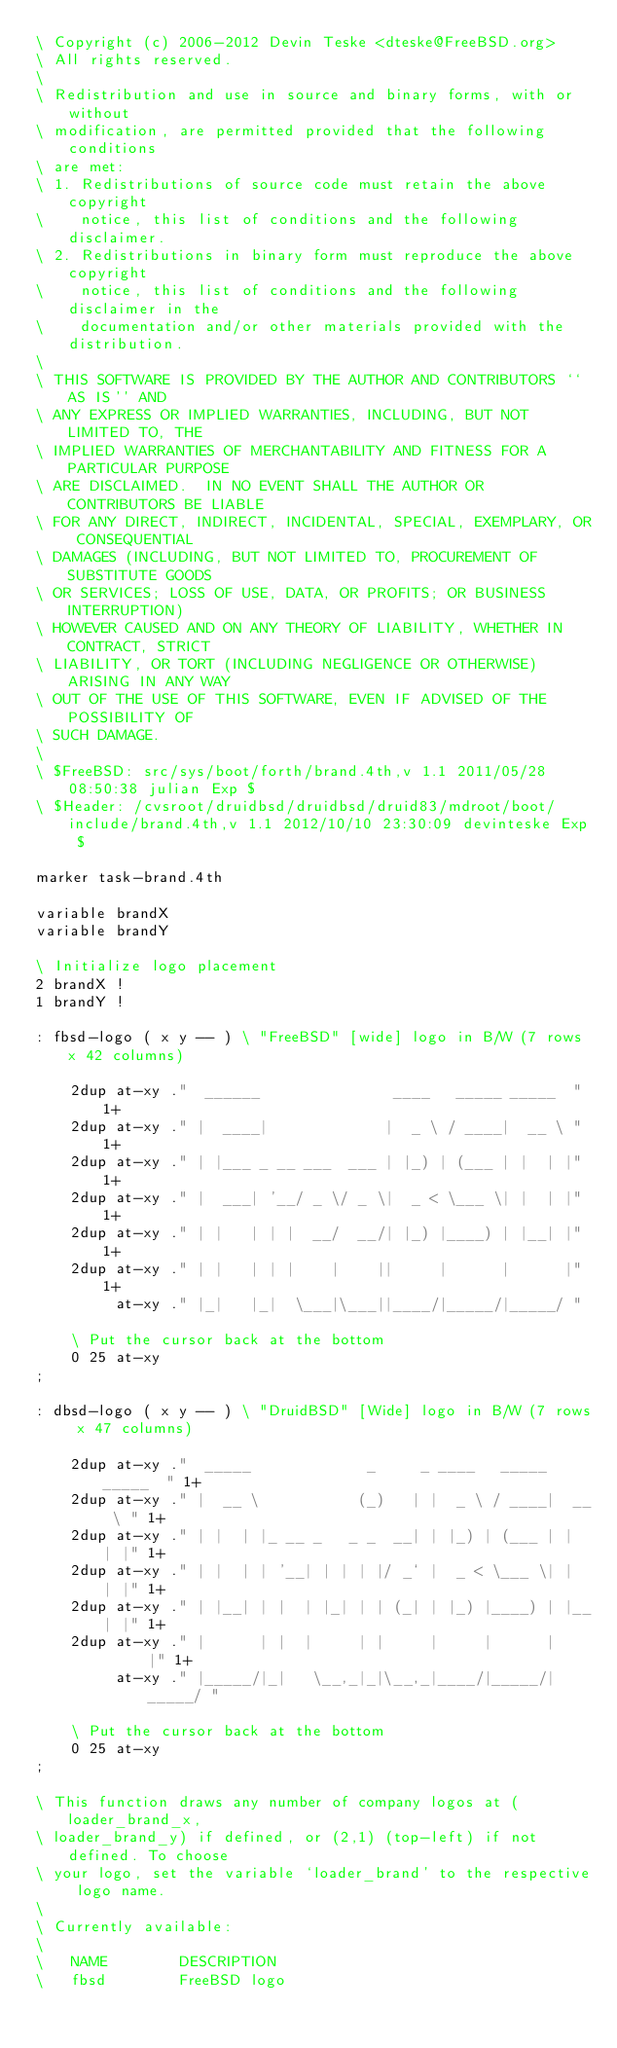<code> <loc_0><loc_0><loc_500><loc_500><_Forth_>\ Copyright (c) 2006-2012 Devin Teske <dteske@FreeBSD.org>
\ All rights reserved.
\ 
\ Redistribution and use in source and binary forms, with or without
\ modification, are permitted provided that the following conditions
\ are met:
\ 1. Redistributions of source code must retain the above copyright
\    notice, this list of conditions and the following disclaimer.
\ 2. Redistributions in binary form must reproduce the above copyright
\    notice, this list of conditions and the following disclaimer in the
\    documentation and/or other materials provided with the distribution.
\ 
\ THIS SOFTWARE IS PROVIDED BY THE AUTHOR AND CONTRIBUTORS ``AS IS'' AND
\ ANY EXPRESS OR IMPLIED WARRANTIES, INCLUDING, BUT NOT LIMITED TO, THE
\ IMPLIED WARRANTIES OF MERCHANTABILITY AND FITNESS FOR A PARTICULAR PURPOSE
\ ARE DISCLAIMED.  IN NO EVENT SHALL THE AUTHOR OR CONTRIBUTORS BE LIABLE
\ FOR ANY DIRECT, INDIRECT, INCIDENTAL, SPECIAL, EXEMPLARY, OR CONSEQUENTIAL
\ DAMAGES (INCLUDING, BUT NOT LIMITED TO, PROCUREMENT OF SUBSTITUTE GOODS
\ OR SERVICES; LOSS OF USE, DATA, OR PROFITS; OR BUSINESS INTERRUPTION)
\ HOWEVER CAUSED AND ON ANY THEORY OF LIABILITY, WHETHER IN CONTRACT, STRICT
\ LIABILITY, OR TORT (INCLUDING NEGLIGENCE OR OTHERWISE) ARISING IN ANY WAY
\ OUT OF THE USE OF THIS SOFTWARE, EVEN IF ADVISED OF THE POSSIBILITY OF
\ SUCH DAMAGE.
\ 
\ $FreeBSD: src/sys/boot/forth/brand.4th,v 1.1 2011/05/28 08:50:38 julian Exp $
\ $Header: /cvsroot/druidbsd/druidbsd/druid83/mdroot/boot/include/brand.4th,v 1.1 2012/10/10 23:30:09 devinteske Exp $

marker task-brand.4th

variable brandX
variable brandY

\ Initialize logo placement
2 brandX !
1 brandY !

: fbsd-logo ( x y -- ) \ "FreeBSD" [wide] logo in B/W (7 rows x 42 columns)

	2dup at-xy ."  ______               ____   _____ _____  " 1+
	2dup at-xy ." |  ____|             |  _ \ / ____|  __ \ " 1+
	2dup at-xy ." | |___ _ __ ___  ___ | |_) | (___ | |  | |" 1+
	2dup at-xy ." |  ___| '__/ _ \/ _ \|  _ < \___ \| |  | |" 1+
	2dup at-xy ." | |   | | |  __/  __/| |_) |____) | |__| |" 1+
	2dup at-xy ." | |   | | |    |    ||     |      |      |" 1+
	     at-xy ." |_|   |_|  \___|\___||____/|_____/|_____/ "

	\ Put the cursor back at the bottom
	0 25 at-xy
;

: dbsd-logo ( x y -- ) \ "DruidBSD" [Wide] logo in B/W (7 rows x 47 columns)

	2dup at-xy ."  _____             _     _ ____   _____ _____  " 1+
	2dup at-xy ." |  __ \           (_)   | |  _ \ / ____|  __ \ " 1+
	2dup at-xy ." | |  | |_ __ _   _ _  __| | |_) | (___ | |  | |" 1+
	2dup at-xy ." | |  | | '__| | | | |/ _` |  _ < \___ \| |  | |" 1+
	2dup at-xy ." | |__| | |  | |_| | | (_| | |_) |____) | |__| |" 1+
	2dup at-xy ." |      | |  |     | |     |     |      |      |" 1+
	     at-xy ." |_____/|_|   \__,_|_|\__,_|____/|_____/|_____/ "

	\ Put the cursor back at the bottom
	0 25 at-xy
;

\ This function draws any number of company logos at (loader_brand_x,
\ loader_brand_y) if defined, or (2,1) (top-left) if not defined. To choose
\ your logo, set the variable `loader_brand' to the respective logo name.
\ 
\ Currently available:
\
\ 	NAME        DESCRIPTION
\ 	fbsd        FreeBSD logo</code> 